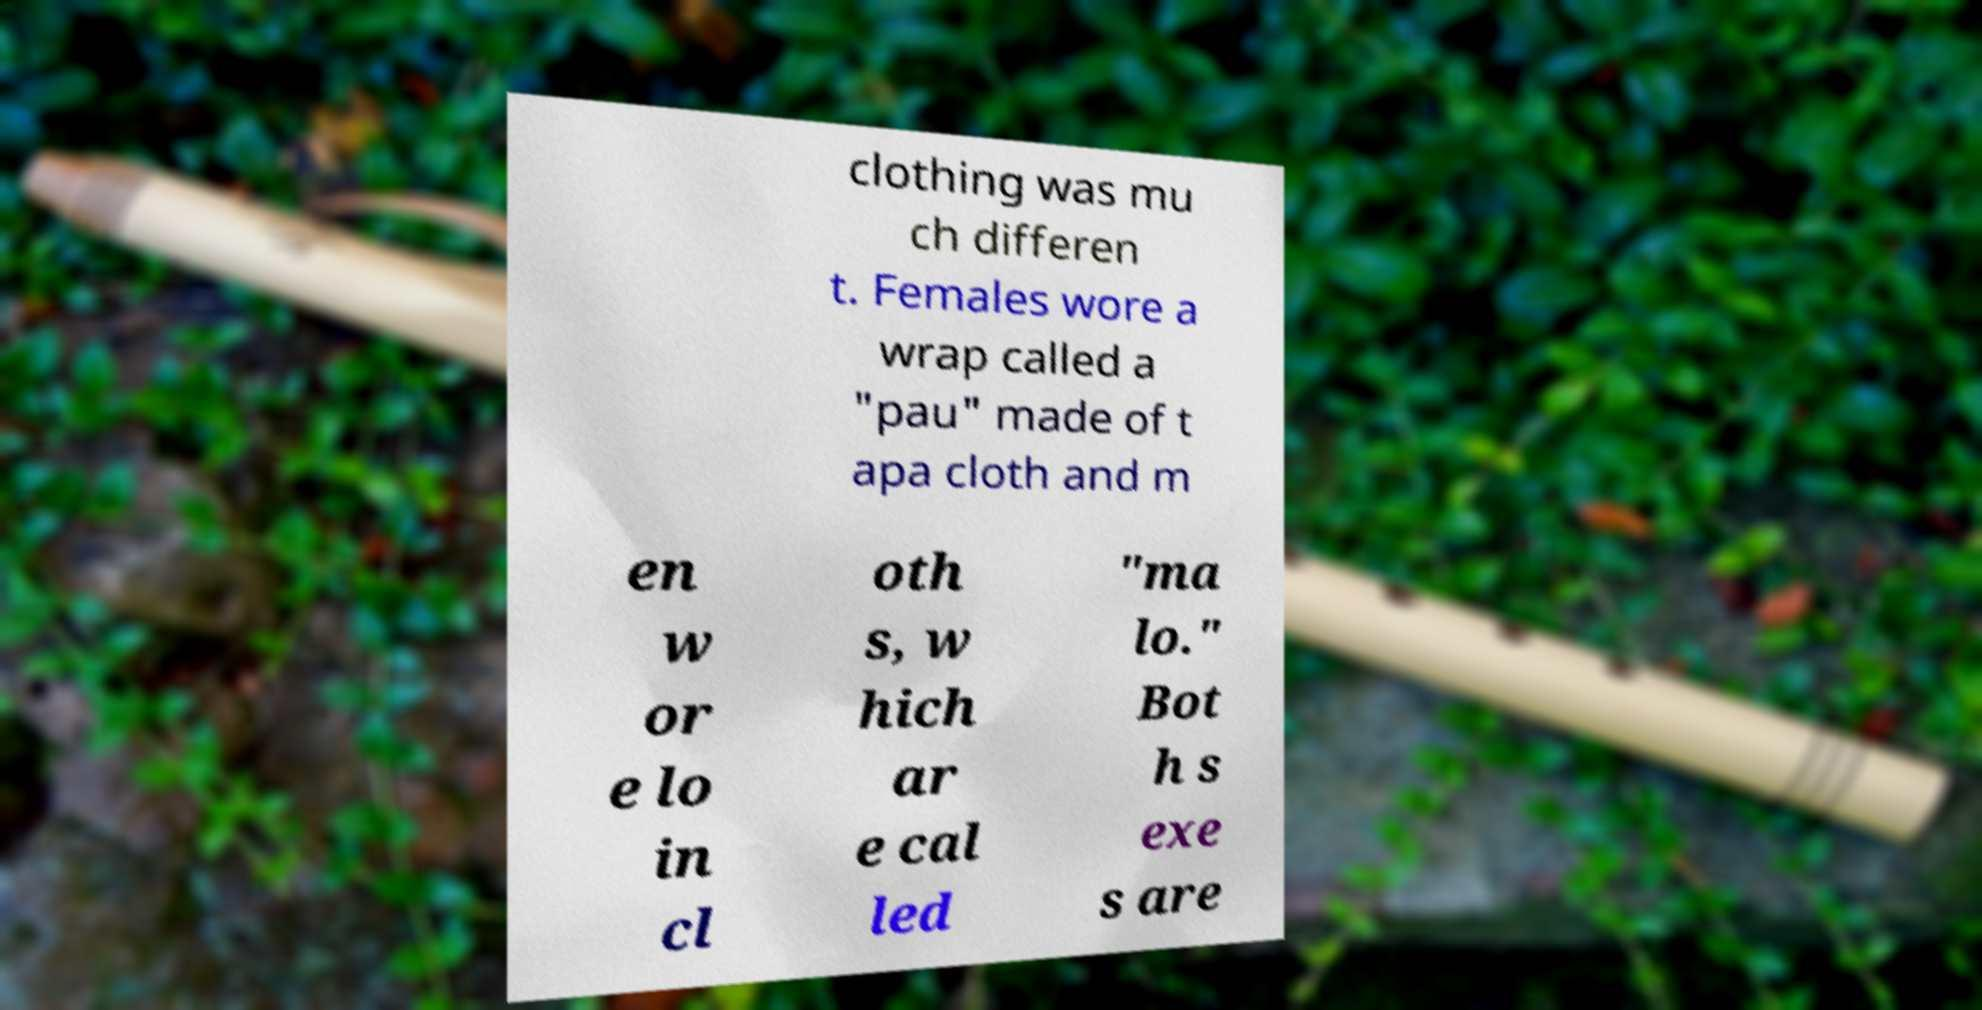What messages or text are displayed in this image? I need them in a readable, typed format. clothing was mu ch differen t. Females wore a wrap called a "pau" made of t apa cloth and m en w or e lo in cl oth s, w hich ar e cal led "ma lo." Bot h s exe s are 